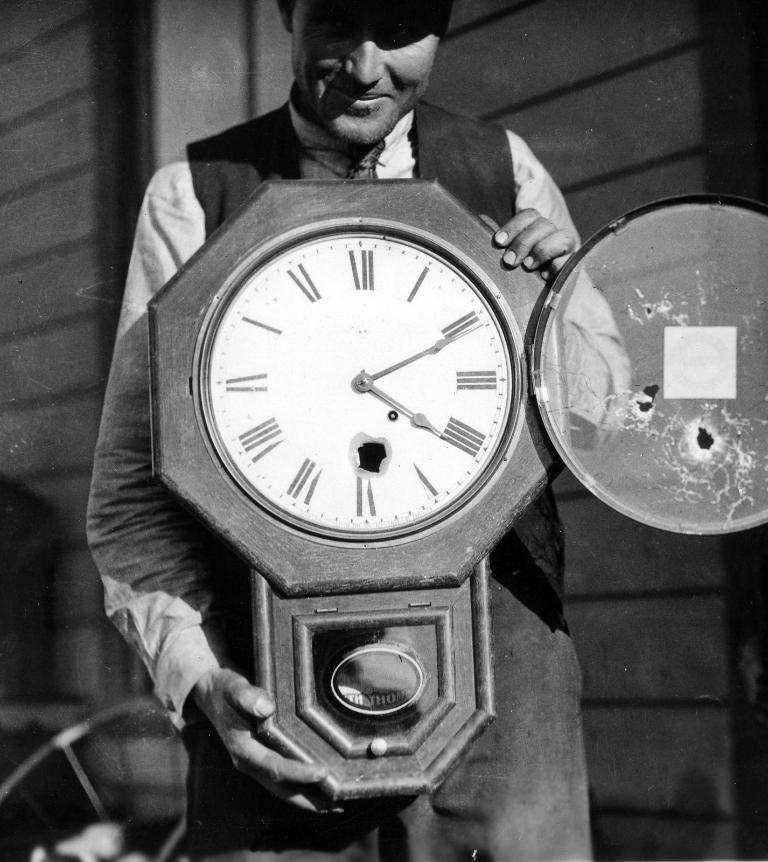How would you summarize this image in a sentence or two? In the middle of the image a person is standing and holding a clock. Behind him there is a wall and chair. 